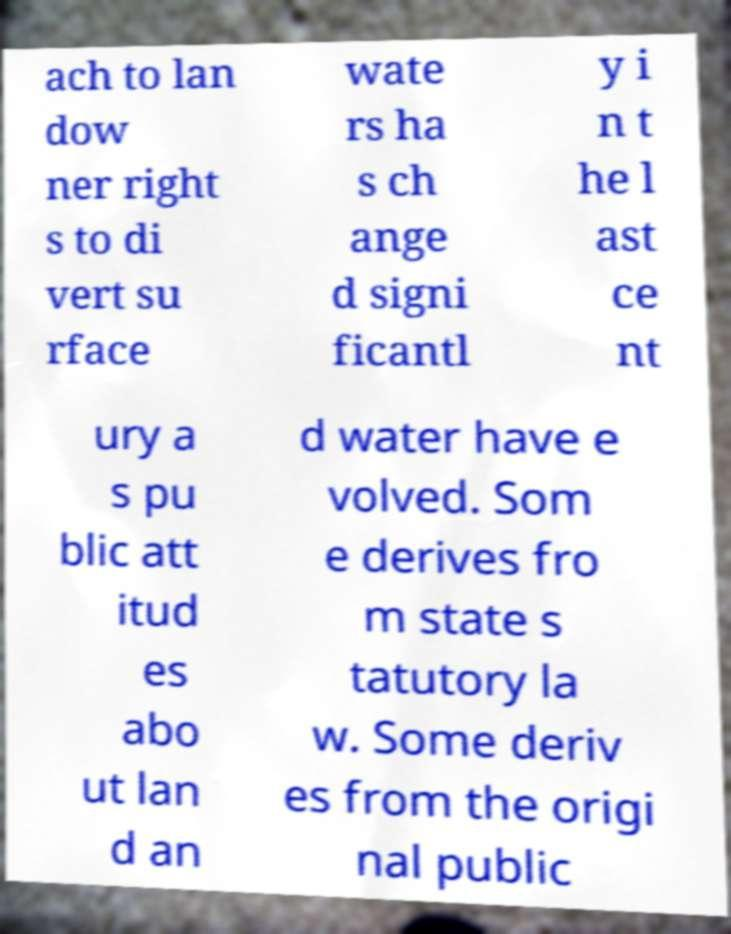I need the written content from this picture converted into text. Can you do that? ach to lan dow ner right s to di vert su rface wate rs ha s ch ange d signi ficantl y i n t he l ast ce nt ury a s pu blic att itud es abo ut lan d an d water have e volved. Som e derives fro m state s tatutory la w. Some deriv es from the origi nal public 